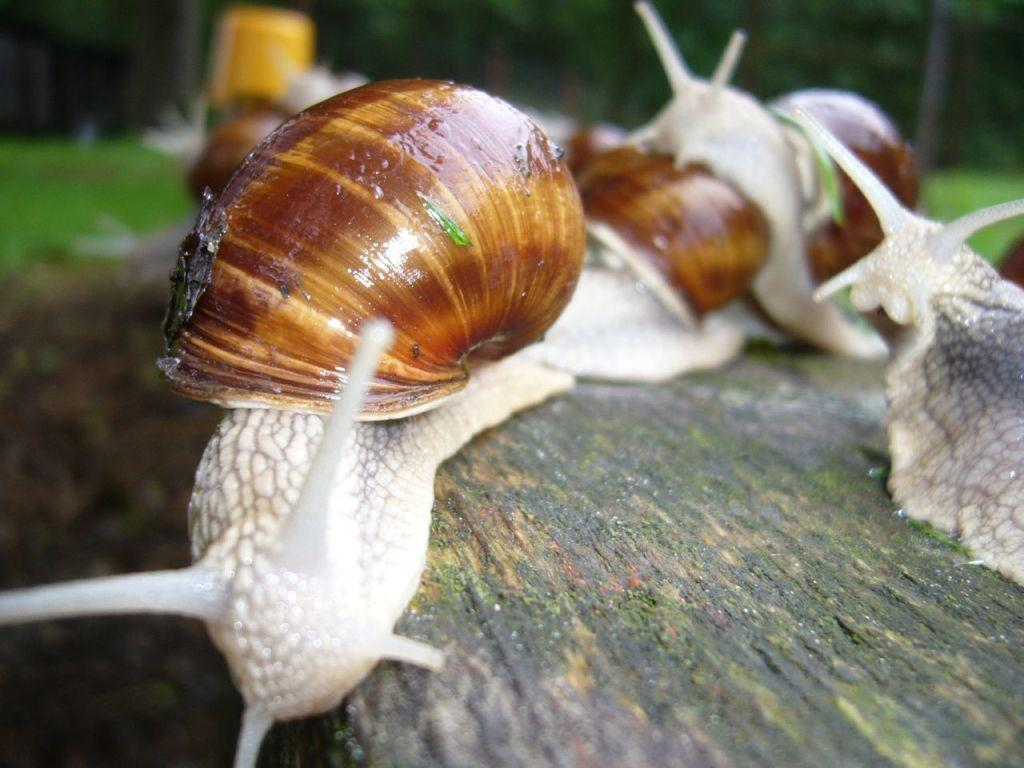What type of creatures can be seen in the image? There are insects in the image. How would you describe the background of the image? The background of the image is blurred. What can be seen in the background of the image? There is greenery visible in the background of the image. What type of apparatus is being used to kick the liquid in the image? There is no apparatus or liquid present in the image; it features insects and a blurred background with greenery. 